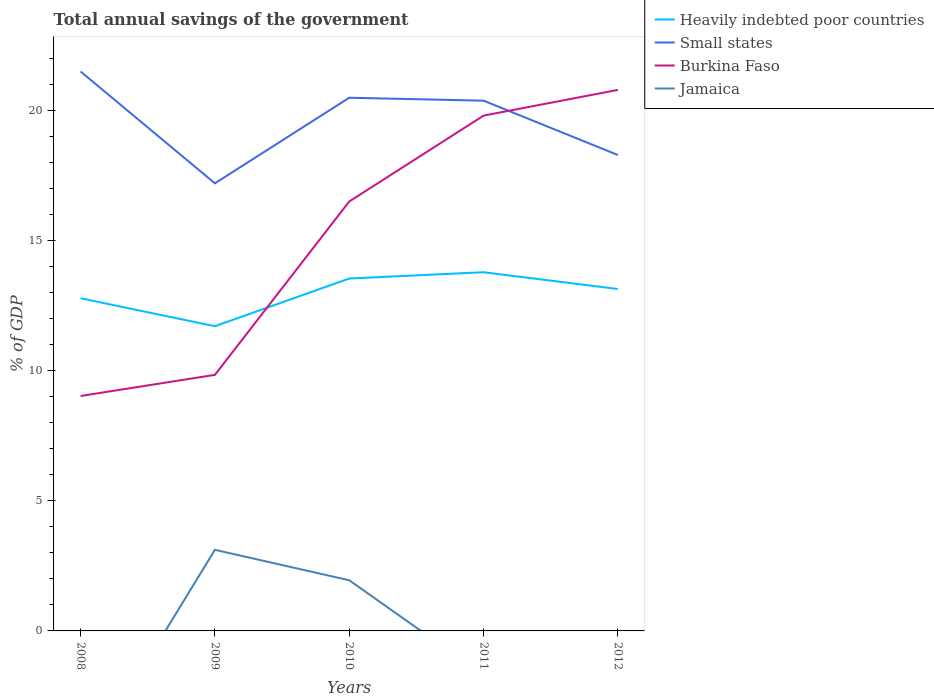Does the line corresponding to Burkina Faso intersect with the line corresponding to Small states?
Offer a very short reply. Yes. Across all years, what is the maximum total annual savings of the government in Burkina Faso?
Your answer should be very brief. 9.04. What is the total total annual savings of the government in Heavily indebted poor countries in the graph?
Your answer should be compact. -1.83. What is the difference between the highest and the second highest total annual savings of the government in Small states?
Give a very brief answer. 4.3. What is the difference between the highest and the lowest total annual savings of the government in Heavily indebted poor countries?
Make the answer very short. 3. Is the total annual savings of the government in Burkina Faso strictly greater than the total annual savings of the government in Small states over the years?
Your answer should be very brief. No. How many years are there in the graph?
Provide a succinct answer. 5. Does the graph contain any zero values?
Your response must be concise. Yes. Where does the legend appear in the graph?
Provide a succinct answer. Top right. What is the title of the graph?
Provide a short and direct response. Total annual savings of the government. Does "Cameroon" appear as one of the legend labels in the graph?
Your response must be concise. No. What is the label or title of the Y-axis?
Keep it short and to the point. % of GDP. What is the % of GDP in Heavily indebted poor countries in 2008?
Your response must be concise. 12.8. What is the % of GDP of Small states in 2008?
Offer a very short reply. 21.52. What is the % of GDP of Burkina Faso in 2008?
Your answer should be very brief. 9.04. What is the % of GDP in Jamaica in 2008?
Provide a short and direct response. 0. What is the % of GDP in Heavily indebted poor countries in 2009?
Give a very brief answer. 11.72. What is the % of GDP of Small states in 2009?
Make the answer very short. 17.22. What is the % of GDP of Burkina Faso in 2009?
Your response must be concise. 9.85. What is the % of GDP in Jamaica in 2009?
Provide a succinct answer. 3.12. What is the % of GDP of Heavily indebted poor countries in 2010?
Offer a terse response. 13.55. What is the % of GDP in Small states in 2010?
Offer a terse response. 20.51. What is the % of GDP of Burkina Faso in 2010?
Keep it short and to the point. 16.52. What is the % of GDP of Jamaica in 2010?
Ensure brevity in your answer.  1.95. What is the % of GDP of Heavily indebted poor countries in 2011?
Provide a succinct answer. 13.8. What is the % of GDP of Small states in 2011?
Provide a short and direct response. 20.4. What is the % of GDP in Burkina Faso in 2011?
Keep it short and to the point. 19.82. What is the % of GDP in Jamaica in 2011?
Provide a short and direct response. 0. What is the % of GDP of Heavily indebted poor countries in 2012?
Keep it short and to the point. 13.15. What is the % of GDP in Small states in 2012?
Provide a succinct answer. 18.3. What is the % of GDP in Burkina Faso in 2012?
Provide a succinct answer. 20.81. Across all years, what is the maximum % of GDP in Heavily indebted poor countries?
Offer a terse response. 13.8. Across all years, what is the maximum % of GDP of Small states?
Ensure brevity in your answer.  21.52. Across all years, what is the maximum % of GDP of Burkina Faso?
Your response must be concise. 20.81. Across all years, what is the maximum % of GDP of Jamaica?
Give a very brief answer. 3.12. Across all years, what is the minimum % of GDP of Heavily indebted poor countries?
Ensure brevity in your answer.  11.72. Across all years, what is the minimum % of GDP in Small states?
Give a very brief answer. 17.22. Across all years, what is the minimum % of GDP of Burkina Faso?
Provide a succinct answer. 9.04. Across all years, what is the minimum % of GDP in Jamaica?
Offer a terse response. 0. What is the total % of GDP in Heavily indebted poor countries in the graph?
Offer a very short reply. 65.02. What is the total % of GDP in Small states in the graph?
Your response must be concise. 97.94. What is the total % of GDP of Burkina Faso in the graph?
Your response must be concise. 76.03. What is the total % of GDP in Jamaica in the graph?
Make the answer very short. 5.07. What is the difference between the % of GDP in Heavily indebted poor countries in 2008 and that in 2009?
Your answer should be compact. 1.08. What is the difference between the % of GDP of Small states in 2008 and that in 2009?
Your response must be concise. 4.3. What is the difference between the % of GDP in Burkina Faso in 2008 and that in 2009?
Provide a short and direct response. -0.81. What is the difference between the % of GDP of Heavily indebted poor countries in 2008 and that in 2010?
Provide a short and direct response. -0.76. What is the difference between the % of GDP in Small states in 2008 and that in 2010?
Ensure brevity in your answer.  1.01. What is the difference between the % of GDP of Burkina Faso in 2008 and that in 2010?
Give a very brief answer. -7.48. What is the difference between the % of GDP of Heavily indebted poor countries in 2008 and that in 2011?
Your answer should be compact. -1. What is the difference between the % of GDP in Small states in 2008 and that in 2011?
Make the answer very short. 1.12. What is the difference between the % of GDP in Burkina Faso in 2008 and that in 2011?
Keep it short and to the point. -10.78. What is the difference between the % of GDP of Heavily indebted poor countries in 2008 and that in 2012?
Provide a short and direct response. -0.36. What is the difference between the % of GDP of Small states in 2008 and that in 2012?
Provide a short and direct response. 3.21. What is the difference between the % of GDP in Burkina Faso in 2008 and that in 2012?
Your answer should be compact. -11.77. What is the difference between the % of GDP in Heavily indebted poor countries in 2009 and that in 2010?
Offer a terse response. -1.83. What is the difference between the % of GDP in Small states in 2009 and that in 2010?
Give a very brief answer. -3.29. What is the difference between the % of GDP of Burkina Faso in 2009 and that in 2010?
Make the answer very short. -6.67. What is the difference between the % of GDP in Jamaica in 2009 and that in 2010?
Ensure brevity in your answer.  1.17. What is the difference between the % of GDP of Heavily indebted poor countries in 2009 and that in 2011?
Your response must be concise. -2.08. What is the difference between the % of GDP of Small states in 2009 and that in 2011?
Offer a terse response. -3.18. What is the difference between the % of GDP of Burkina Faso in 2009 and that in 2011?
Give a very brief answer. -9.97. What is the difference between the % of GDP in Heavily indebted poor countries in 2009 and that in 2012?
Offer a very short reply. -1.43. What is the difference between the % of GDP in Small states in 2009 and that in 2012?
Provide a succinct answer. -1.09. What is the difference between the % of GDP of Burkina Faso in 2009 and that in 2012?
Make the answer very short. -10.96. What is the difference between the % of GDP in Heavily indebted poor countries in 2010 and that in 2011?
Give a very brief answer. -0.24. What is the difference between the % of GDP in Small states in 2010 and that in 2011?
Make the answer very short. 0.11. What is the difference between the % of GDP of Burkina Faso in 2010 and that in 2011?
Make the answer very short. -3.3. What is the difference between the % of GDP of Heavily indebted poor countries in 2010 and that in 2012?
Your response must be concise. 0.4. What is the difference between the % of GDP in Small states in 2010 and that in 2012?
Keep it short and to the point. 2.2. What is the difference between the % of GDP in Burkina Faso in 2010 and that in 2012?
Offer a very short reply. -4.29. What is the difference between the % of GDP of Heavily indebted poor countries in 2011 and that in 2012?
Offer a very short reply. 0.65. What is the difference between the % of GDP in Small states in 2011 and that in 2012?
Your answer should be compact. 2.09. What is the difference between the % of GDP in Burkina Faso in 2011 and that in 2012?
Provide a short and direct response. -0.99. What is the difference between the % of GDP of Heavily indebted poor countries in 2008 and the % of GDP of Small states in 2009?
Make the answer very short. -4.42. What is the difference between the % of GDP of Heavily indebted poor countries in 2008 and the % of GDP of Burkina Faso in 2009?
Offer a very short reply. 2.95. What is the difference between the % of GDP of Heavily indebted poor countries in 2008 and the % of GDP of Jamaica in 2009?
Ensure brevity in your answer.  9.68. What is the difference between the % of GDP in Small states in 2008 and the % of GDP in Burkina Faso in 2009?
Your answer should be very brief. 11.67. What is the difference between the % of GDP in Small states in 2008 and the % of GDP in Jamaica in 2009?
Your answer should be very brief. 18.4. What is the difference between the % of GDP in Burkina Faso in 2008 and the % of GDP in Jamaica in 2009?
Your answer should be very brief. 5.92. What is the difference between the % of GDP in Heavily indebted poor countries in 2008 and the % of GDP in Small states in 2010?
Give a very brief answer. -7.71. What is the difference between the % of GDP of Heavily indebted poor countries in 2008 and the % of GDP of Burkina Faso in 2010?
Offer a very short reply. -3.72. What is the difference between the % of GDP in Heavily indebted poor countries in 2008 and the % of GDP in Jamaica in 2010?
Provide a succinct answer. 10.85. What is the difference between the % of GDP of Small states in 2008 and the % of GDP of Burkina Faso in 2010?
Offer a terse response. 5. What is the difference between the % of GDP in Small states in 2008 and the % of GDP in Jamaica in 2010?
Your response must be concise. 19.57. What is the difference between the % of GDP in Burkina Faso in 2008 and the % of GDP in Jamaica in 2010?
Make the answer very short. 7.09. What is the difference between the % of GDP in Heavily indebted poor countries in 2008 and the % of GDP in Small states in 2011?
Your answer should be compact. -7.6. What is the difference between the % of GDP of Heavily indebted poor countries in 2008 and the % of GDP of Burkina Faso in 2011?
Your answer should be compact. -7.02. What is the difference between the % of GDP of Small states in 2008 and the % of GDP of Burkina Faso in 2011?
Your answer should be very brief. 1.7. What is the difference between the % of GDP of Heavily indebted poor countries in 2008 and the % of GDP of Small states in 2012?
Give a very brief answer. -5.51. What is the difference between the % of GDP of Heavily indebted poor countries in 2008 and the % of GDP of Burkina Faso in 2012?
Provide a succinct answer. -8.01. What is the difference between the % of GDP of Small states in 2008 and the % of GDP of Burkina Faso in 2012?
Make the answer very short. 0.71. What is the difference between the % of GDP of Heavily indebted poor countries in 2009 and the % of GDP of Small states in 2010?
Make the answer very short. -8.79. What is the difference between the % of GDP in Heavily indebted poor countries in 2009 and the % of GDP in Burkina Faso in 2010?
Give a very brief answer. -4.8. What is the difference between the % of GDP of Heavily indebted poor countries in 2009 and the % of GDP of Jamaica in 2010?
Keep it short and to the point. 9.77. What is the difference between the % of GDP in Small states in 2009 and the % of GDP in Burkina Faso in 2010?
Offer a very short reply. 0.7. What is the difference between the % of GDP of Small states in 2009 and the % of GDP of Jamaica in 2010?
Offer a terse response. 15.27. What is the difference between the % of GDP of Burkina Faso in 2009 and the % of GDP of Jamaica in 2010?
Provide a succinct answer. 7.9. What is the difference between the % of GDP of Heavily indebted poor countries in 2009 and the % of GDP of Small states in 2011?
Your answer should be compact. -8.68. What is the difference between the % of GDP in Heavily indebted poor countries in 2009 and the % of GDP in Burkina Faso in 2011?
Your response must be concise. -8.1. What is the difference between the % of GDP of Small states in 2009 and the % of GDP of Burkina Faso in 2011?
Make the answer very short. -2.6. What is the difference between the % of GDP in Heavily indebted poor countries in 2009 and the % of GDP in Small states in 2012?
Your answer should be very brief. -6.59. What is the difference between the % of GDP in Heavily indebted poor countries in 2009 and the % of GDP in Burkina Faso in 2012?
Your response must be concise. -9.09. What is the difference between the % of GDP in Small states in 2009 and the % of GDP in Burkina Faso in 2012?
Offer a very short reply. -3.59. What is the difference between the % of GDP in Heavily indebted poor countries in 2010 and the % of GDP in Small states in 2011?
Provide a succinct answer. -6.84. What is the difference between the % of GDP of Heavily indebted poor countries in 2010 and the % of GDP of Burkina Faso in 2011?
Keep it short and to the point. -6.27. What is the difference between the % of GDP in Small states in 2010 and the % of GDP in Burkina Faso in 2011?
Ensure brevity in your answer.  0.69. What is the difference between the % of GDP in Heavily indebted poor countries in 2010 and the % of GDP in Small states in 2012?
Make the answer very short. -4.75. What is the difference between the % of GDP of Heavily indebted poor countries in 2010 and the % of GDP of Burkina Faso in 2012?
Offer a very short reply. -7.26. What is the difference between the % of GDP of Small states in 2010 and the % of GDP of Burkina Faso in 2012?
Offer a very short reply. -0.3. What is the difference between the % of GDP of Heavily indebted poor countries in 2011 and the % of GDP of Small states in 2012?
Provide a short and direct response. -4.51. What is the difference between the % of GDP of Heavily indebted poor countries in 2011 and the % of GDP of Burkina Faso in 2012?
Ensure brevity in your answer.  -7.01. What is the difference between the % of GDP in Small states in 2011 and the % of GDP in Burkina Faso in 2012?
Your answer should be compact. -0.41. What is the average % of GDP of Heavily indebted poor countries per year?
Ensure brevity in your answer.  13. What is the average % of GDP in Small states per year?
Ensure brevity in your answer.  19.59. What is the average % of GDP in Burkina Faso per year?
Keep it short and to the point. 15.21. What is the average % of GDP in Jamaica per year?
Offer a very short reply. 1.01. In the year 2008, what is the difference between the % of GDP of Heavily indebted poor countries and % of GDP of Small states?
Offer a terse response. -8.72. In the year 2008, what is the difference between the % of GDP in Heavily indebted poor countries and % of GDP in Burkina Faso?
Offer a very short reply. 3.76. In the year 2008, what is the difference between the % of GDP of Small states and % of GDP of Burkina Faso?
Your response must be concise. 12.48. In the year 2009, what is the difference between the % of GDP of Heavily indebted poor countries and % of GDP of Small states?
Provide a succinct answer. -5.5. In the year 2009, what is the difference between the % of GDP in Heavily indebted poor countries and % of GDP in Burkina Faso?
Make the answer very short. 1.87. In the year 2009, what is the difference between the % of GDP of Heavily indebted poor countries and % of GDP of Jamaica?
Provide a short and direct response. 8.6. In the year 2009, what is the difference between the % of GDP of Small states and % of GDP of Burkina Faso?
Make the answer very short. 7.37. In the year 2009, what is the difference between the % of GDP in Small states and % of GDP in Jamaica?
Make the answer very short. 14.1. In the year 2009, what is the difference between the % of GDP of Burkina Faso and % of GDP of Jamaica?
Provide a succinct answer. 6.73. In the year 2010, what is the difference between the % of GDP of Heavily indebted poor countries and % of GDP of Small states?
Your answer should be compact. -6.95. In the year 2010, what is the difference between the % of GDP in Heavily indebted poor countries and % of GDP in Burkina Faso?
Keep it short and to the point. -2.96. In the year 2010, what is the difference between the % of GDP of Heavily indebted poor countries and % of GDP of Jamaica?
Offer a very short reply. 11.61. In the year 2010, what is the difference between the % of GDP in Small states and % of GDP in Burkina Faso?
Provide a succinct answer. 3.99. In the year 2010, what is the difference between the % of GDP of Small states and % of GDP of Jamaica?
Make the answer very short. 18.56. In the year 2010, what is the difference between the % of GDP in Burkina Faso and % of GDP in Jamaica?
Offer a terse response. 14.57. In the year 2011, what is the difference between the % of GDP in Heavily indebted poor countries and % of GDP in Small states?
Ensure brevity in your answer.  -6.6. In the year 2011, what is the difference between the % of GDP in Heavily indebted poor countries and % of GDP in Burkina Faso?
Your response must be concise. -6.02. In the year 2011, what is the difference between the % of GDP of Small states and % of GDP of Burkina Faso?
Your answer should be compact. 0.57. In the year 2012, what is the difference between the % of GDP in Heavily indebted poor countries and % of GDP in Small states?
Offer a very short reply. -5.15. In the year 2012, what is the difference between the % of GDP in Heavily indebted poor countries and % of GDP in Burkina Faso?
Ensure brevity in your answer.  -7.66. In the year 2012, what is the difference between the % of GDP of Small states and % of GDP of Burkina Faso?
Keep it short and to the point. -2.51. What is the ratio of the % of GDP of Heavily indebted poor countries in 2008 to that in 2009?
Offer a terse response. 1.09. What is the ratio of the % of GDP of Small states in 2008 to that in 2009?
Give a very brief answer. 1.25. What is the ratio of the % of GDP in Burkina Faso in 2008 to that in 2009?
Give a very brief answer. 0.92. What is the ratio of the % of GDP of Heavily indebted poor countries in 2008 to that in 2010?
Your response must be concise. 0.94. What is the ratio of the % of GDP of Small states in 2008 to that in 2010?
Provide a short and direct response. 1.05. What is the ratio of the % of GDP in Burkina Faso in 2008 to that in 2010?
Your answer should be compact. 0.55. What is the ratio of the % of GDP in Heavily indebted poor countries in 2008 to that in 2011?
Offer a terse response. 0.93. What is the ratio of the % of GDP of Small states in 2008 to that in 2011?
Offer a very short reply. 1.05. What is the ratio of the % of GDP of Burkina Faso in 2008 to that in 2011?
Keep it short and to the point. 0.46. What is the ratio of the % of GDP in Heavily indebted poor countries in 2008 to that in 2012?
Your response must be concise. 0.97. What is the ratio of the % of GDP of Small states in 2008 to that in 2012?
Keep it short and to the point. 1.18. What is the ratio of the % of GDP in Burkina Faso in 2008 to that in 2012?
Your answer should be very brief. 0.43. What is the ratio of the % of GDP of Heavily indebted poor countries in 2009 to that in 2010?
Your answer should be very brief. 0.86. What is the ratio of the % of GDP of Small states in 2009 to that in 2010?
Ensure brevity in your answer.  0.84. What is the ratio of the % of GDP in Burkina Faso in 2009 to that in 2010?
Your answer should be compact. 0.6. What is the ratio of the % of GDP of Jamaica in 2009 to that in 2010?
Keep it short and to the point. 1.6. What is the ratio of the % of GDP of Heavily indebted poor countries in 2009 to that in 2011?
Keep it short and to the point. 0.85. What is the ratio of the % of GDP in Small states in 2009 to that in 2011?
Your response must be concise. 0.84. What is the ratio of the % of GDP of Burkina Faso in 2009 to that in 2011?
Make the answer very short. 0.5. What is the ratio of the % of GDP of Heavily indebted poor countries in 2009 to that in 2012?
Give a very brief answer. 0.89. What is the ratio of the % of GDP in Small states in 2009 to that in 2012?
Make the answer very short. 0.94. What is the ratio of the % of GDP of Burkina Faso in 2009 to that in 2012?
Your response must be concise. 0.47. What is the ratio of the % of GDP in Heavily indebted poor countries in 2010 to that in 2011?
Offer a very short reply. 0.98. What is the ratio of the % of GDP in Burkina Faso in 2010 to that in 2011?
Ensure brevity in your answer.  0.83. What is the ratio of the % of GDP in Heavily indebted poor countries in 2010 to that in 2012?
Ensure brevity in your answer.  1.03. What is the ratio of the % of GDP of Small states in 2010 to that in 2012?
Provide a short and direct response. 1.12. What is the ratio of the % of GDP in Burkina Faso in 2010 to that in 2012?
Make the answer very short. 0.79. What is the ratio of the % of GDP of Heavily indebted poor countries in 2011 to that in 2012?
Offer a terse response. 1.05. What is the ratio of the % of GDP in Small states in 2011 to that in 2012?
Keep it short and to the point. 1.11. What is the ratio of the % of GDP in Burkina Faso in 2011 to that in 2012?
Give a very brief answer. 0.95. What is the difference between the highest and the second highest % of GDP of Heavily indebted poor countries?
Keep it short and to the point. 0.24. What is the difference between the highest and the second highest % of GDP in Small states?
Ensure brevity in your answer.  1.01. What is the difference between the highest and the lowest % of GDP in Heavily indebted poor countries?
Offer a very short reply. 2.08. What is the difference between the highest and the lowest % of GDP of Small states?
Make the answer very short. 4.3. What is the difference between the highest and the lowest % of GDP of Burkina Faso?
Provide a succinct answer. 11.77. What is the difference between the highest and the lowest % of GDP of Jamaica?
Ensure brevity in your answer.  3.12. 